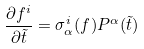<formula> <loc_0><loc_0><loc_500><loc_500>\frac { \partial f ^ { i } } { \partial \tilde { t } } = \sigma ^ { i } _ { \alpha } ( f ) P ^ { \alpha } ( \tilde { t } )</formula> 